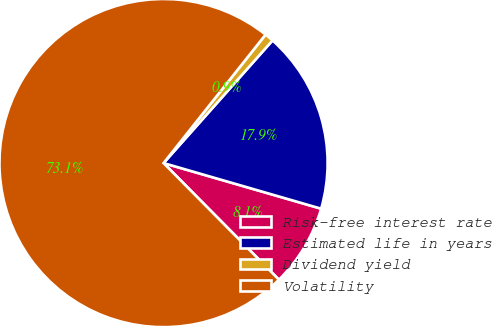Convert chart. <chart><loc_0><loc_0><loc_500><loc_500><pie_chart><fcel>Risk-free interest rate<fcel>Estimated life in years<fcel>Dividend yield<fcel>Volatility<nl><fcel>8.1%<fcel>17.92%<fcel>0.88%<fcel>73.09%<nl></chart> 